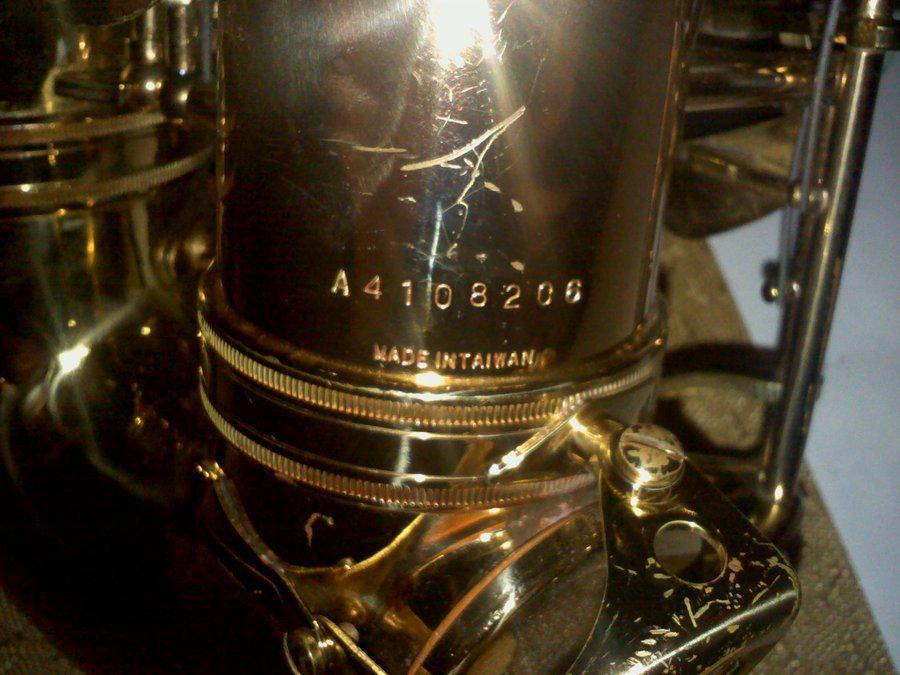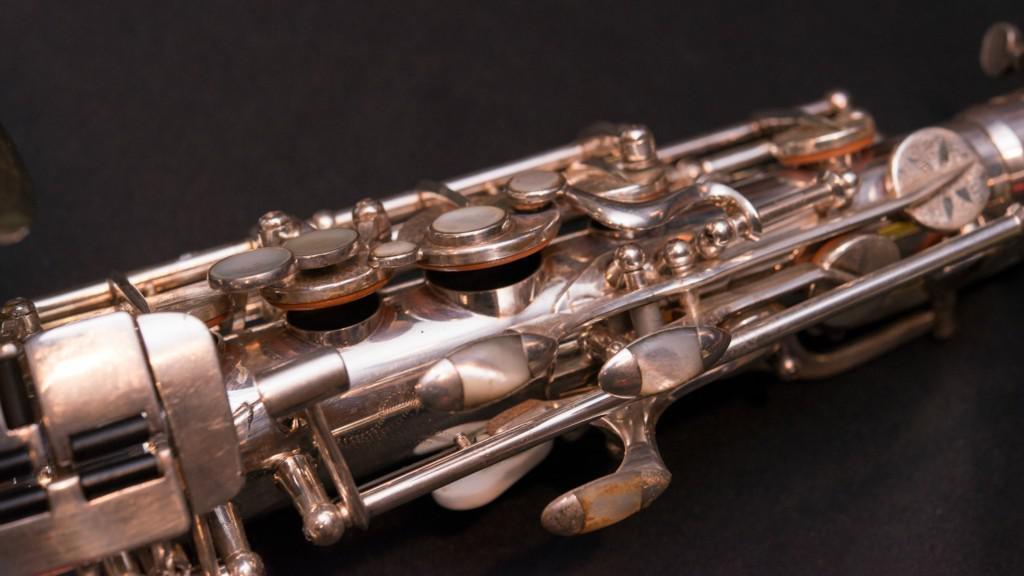The first image is the image on the left, the second image is the image on the right. Assess this claim about the two images: "One image includes the upturned shiny gold bell of at least one saxophone, and the other image shows the etched surface of a saxophone that is more copper colored.". Correct or not? Answer yes or no. No. 